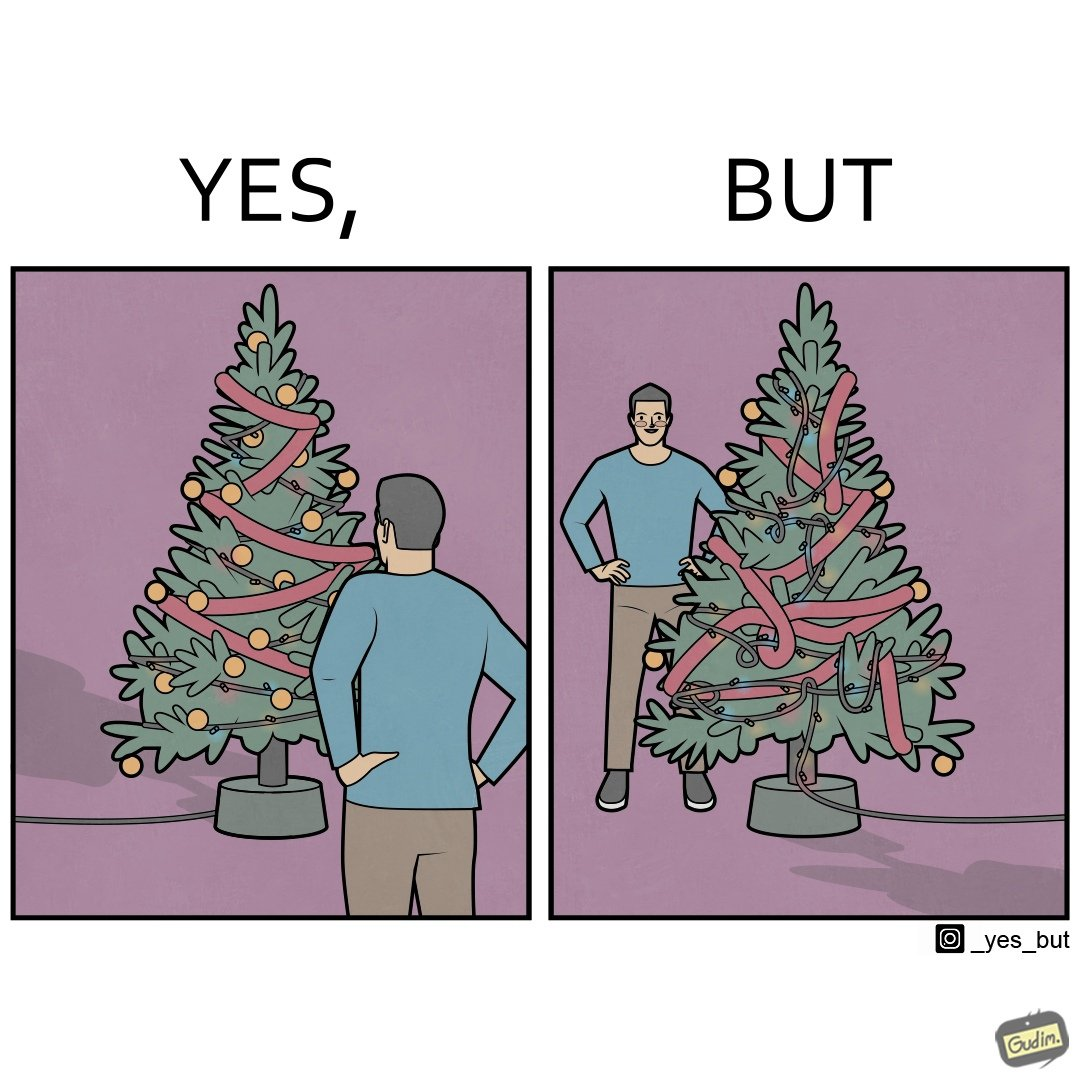What do you see in each half of this image? In the left part of the image: a person looking at a X-mas tree In the right part of the image: a person looking at a X-mas tree on which various bulbs are put and are connected to electricity source 